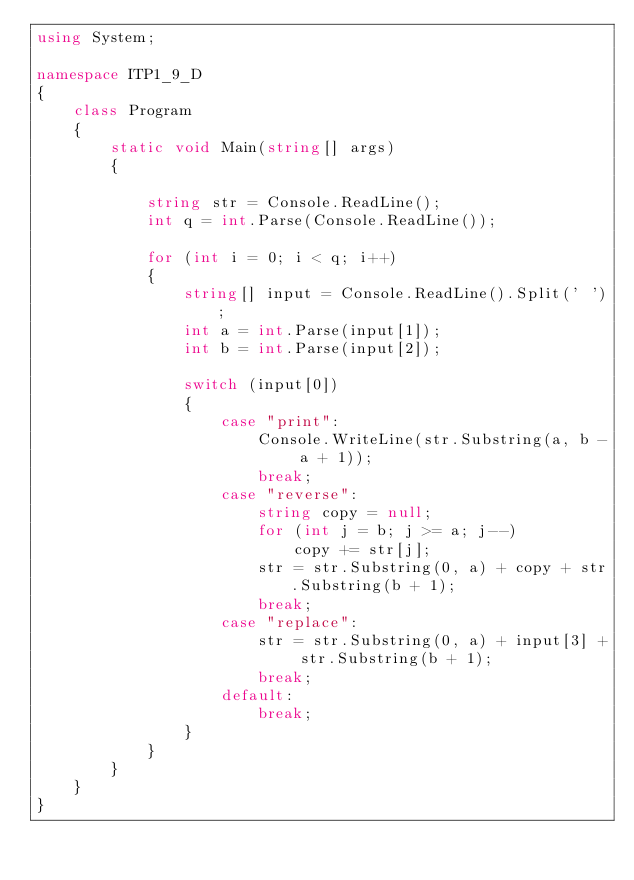Convert code to text. <code><loc_0><loc_0><loc_500><loc_500><_C#_>using System;

namespace ITP1_9_D
{
    class Program
    {
        static void Main(string[] args)
        {

            string str = Console.ReadLine();
            int q = int.Parse(Console.ReadLine());

            for (int i = 0; i < q; i++)
            {
                string[] input = Console.ReadLine().Split(' ');
                int a = int.Parse(input[1]);
                int b = int.Parse(input[2]);

                switch (input[0])
                {
                    case "print":
                        Console.WriteLine(str.Substring(a, b - a + 1));
                        break;
                    case "reverse":
                        string copy = null;
                        for (int j = b; j >= a; j--)
                            copy += str[j];
                        str = str.Substring(0, a) + copy + str.Substring(b + 1);
                        break;
                    case "replace":
                        str = str.Substring(0, a) + input[3] + str.Substring(b + 1);
                        break;
                    default:
                        break;
                }
            }
        }
    }
}</code> 